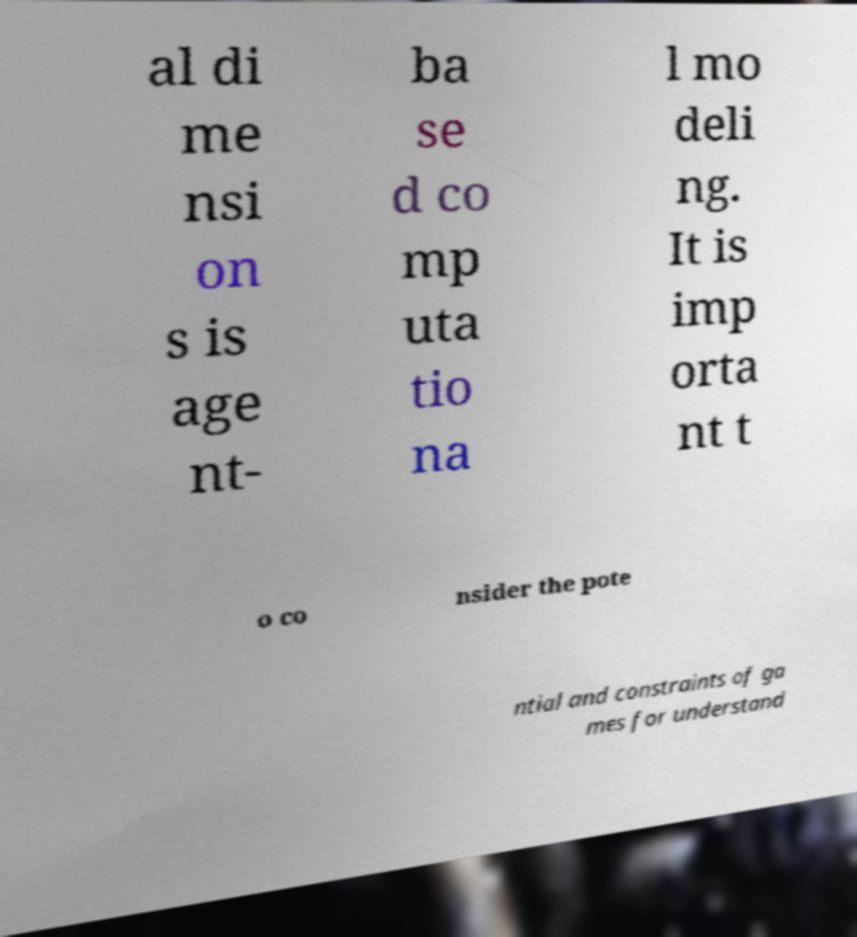I need the written content from this picture converted into text. Can you do that? al di me nsi on s is age nt- ba se d co mp uta tio na l mo deli ng. It is imp orta nt t o co nsider the pote ntial and constraints of ga mes for understand 